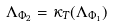Convert formula to latex. <formula><loc_0><loc_0><loc_500><loc_500>\Lambda _ { \Phi _ { 2 } } = \kappa _ { T } ( \Lambda _ { \Phi _ { 1 } } )</formula> 